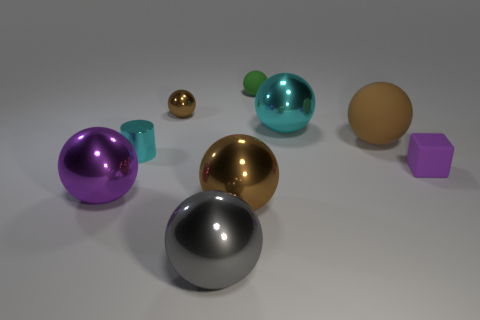Does the large matte thing have the same color as the small shiny ball?
Your answer should be compact. Yes. There is a small metallic cylinder; is it the same color as the large ball that is behind the large matte object?
Your answer should be compact. Yes. There is a block that is the same size as the cyan cylinder; what material is it?
Provide a succinct answer. Rubber. Is the number of large cyan metallic spheres left of the big brown metallic object less than the number of metallic spheres in front of the small cyan thing?
Give a very brief answer. Yes. The brown thing in front of the purple object that is in front of the purple block is what shape?
Give a very brief answer. Sphere. Is there a large purple matte cylinder?
Keep it short and to the point. No. What color is the large metal object behind the cylinder?
Your answer should be compact. Cyan. There is a purple ball; are there any large metallic spheres right of it?
Keep it short and to the point. Yes. Is the number of red shiny spheres greater than the number of brown objects?
Offer a terse response. No. There is a large thing that is to the left of the brown shiny ball behind the big brown ball in front of the tiny block; what color is it?
Your answer should be compact. Purple. 